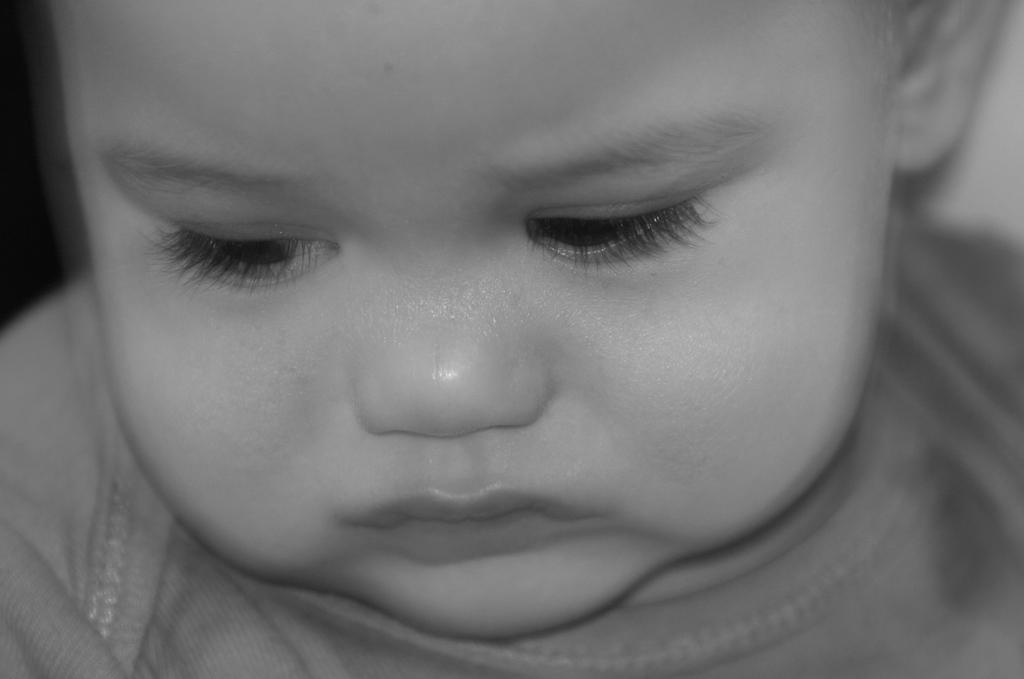What is the color scheme of the image? The image is black and white. What is the main subject of the image? There is the face of a boy in the image. Where is the nest of the queen located in the image? There is no nest or queen present in the image; it only features the face of a boy. 